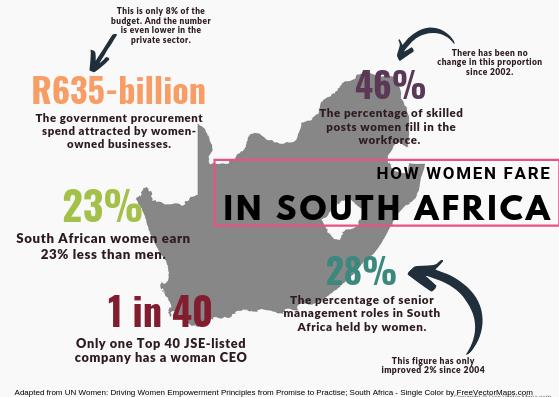List a handful of essential elements in this visual. According to data from South Africa, 77% of men are earning a certain amount. In 2004, the percentage of skilled women in the workforce increased by 28%, 46%, or 23%. The exact percentage was 46%. In the year 2003, there was no change in the percentage of skilled women in the workforce. 